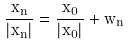Convert formula to latex. <formula><loc_0><loc_0><loc_500><loc_500>\frac { x _ { n } } { | x _ { n } | } = \frac { x _ { 0 } } { | x _ { 0 } | } + w _ { n }</formula> 